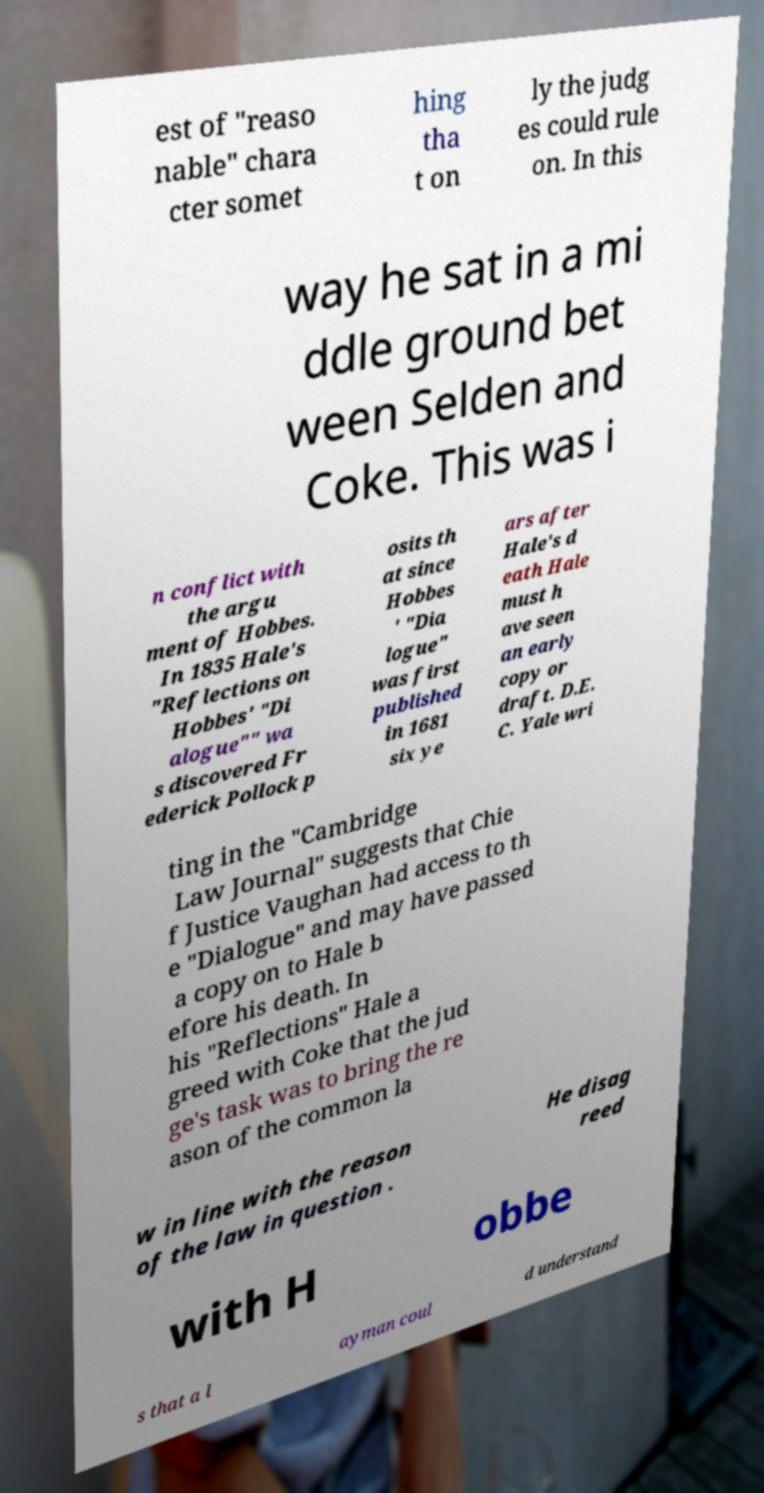Can you accurately transcribe the text from the provided image for me? est of "reaso nable" chara cter somet hing tha t on ly the judg es could rule on. In this way he sat in a mi ddle ground bet ween Selden and Coke. This was i n conflict with the argu ment of Hobbes. In 1835 Hale's "Reflections on Hobbes' "Di alogue"" wa s discovered Fr ederick Pollock p osits th at since Hobbes ' "Dia logue" was first published in 1681 six ye ars after Hale's d eath Hale must h ave seen an early copy or draft. D.E. C. Yale wri ting in the "Cambridge Law Journal" suggests that Chie f Justice Vaughan had access to th e "Dialogue" and may have passed a copy on to Hale b efore his death. In his "Reflections" Hale a greed with Coke that the jud ge's task was to bring the re ason of the common la w in line with the reason of the law in question . He disag reed with H obbe s that a l ayman coul d understand 